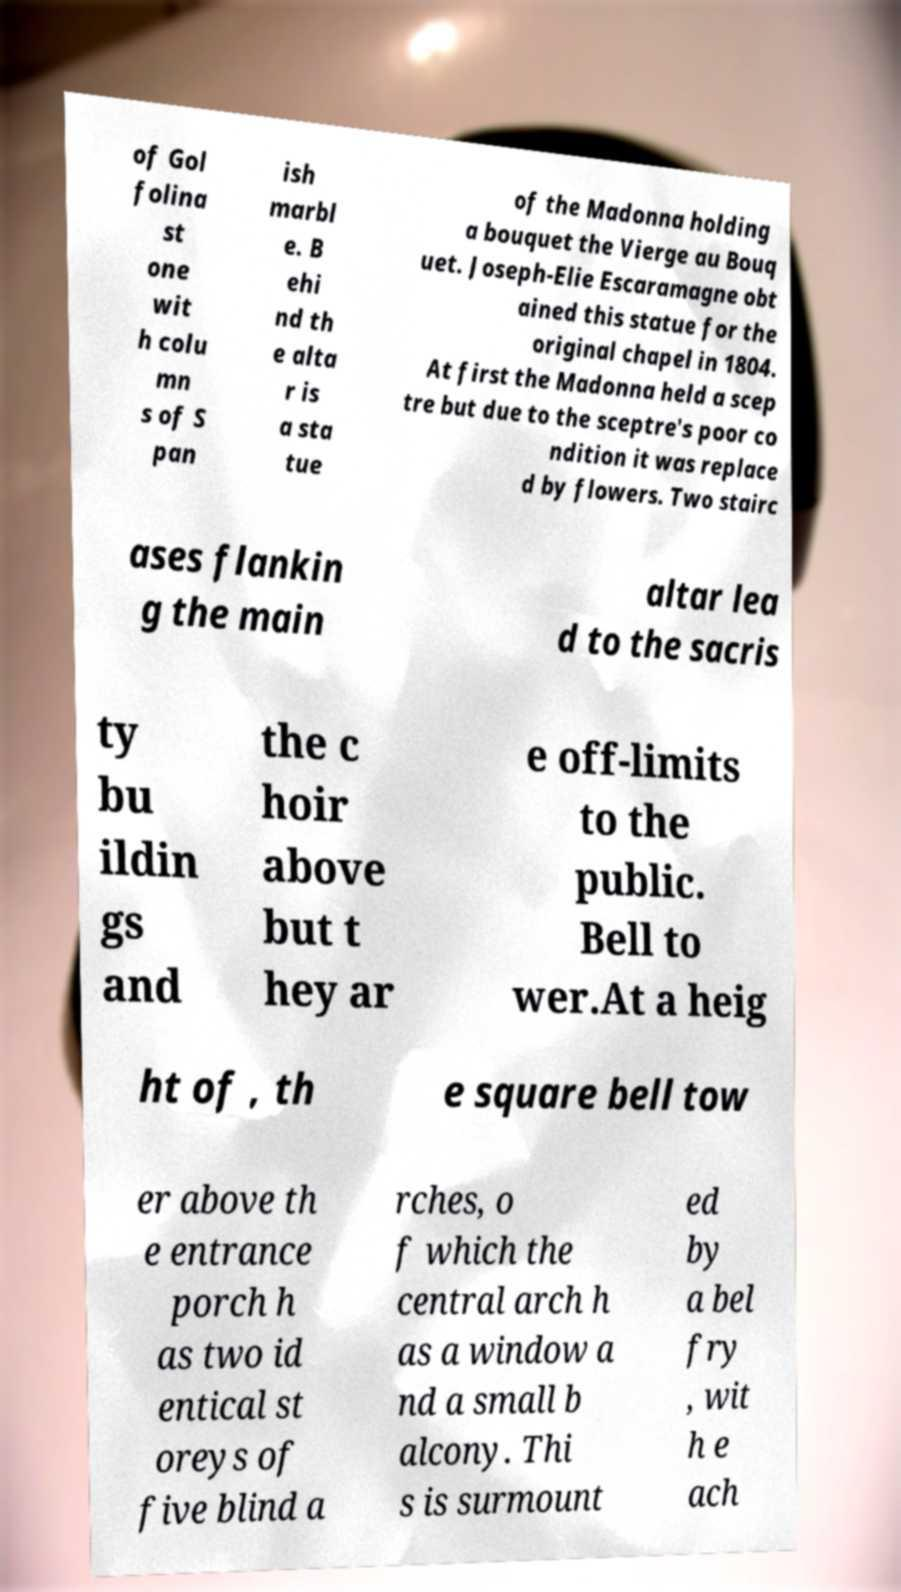Please read and relay the text visible in this image. What does it say? of Gol folina st one wit h colu mn s of S pan ish marbl e. B ehi nd th e alta r is a sta tue of the Madonna holding a bouquet the Vierge au Bouq uet. Joseph-Elie Escaramagne obt ained this statue for the original chapel in 1804. At first the Madonna held a scep tre but due to the sceptre's poor co ndition it was replace d by flowers. Two stairc ases flankin g the main altar lea d to the sacris ty bu ildin gs and the c hoir above but t hey ar e off-limits to the public. Bell to wer.At a heig ht of , th e square bell tow er above th e entrance porch h as two id entical st oreys of five blind a rches, o f which the central arch h as a window a nd a small b alcony. Thi s is surmount ed by a bel fry , wit h e ach 